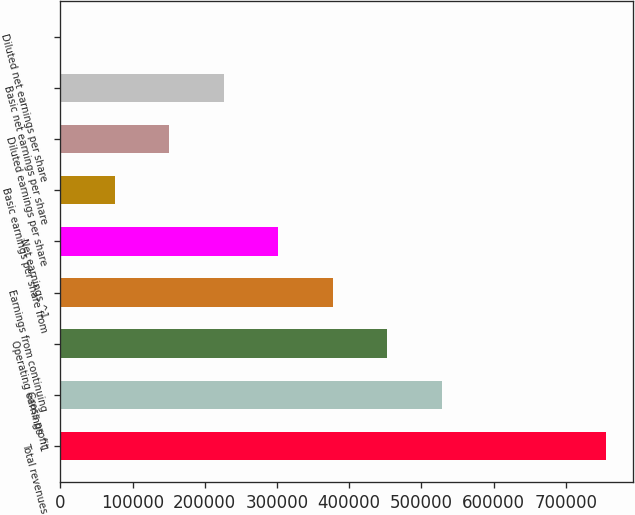<chart> <loc_0><loc_0><loc_500><loc_500><bar_chart><fcel>Total revenues<fcel>Gross profit<fcel>Operating earnings ^1<fcel>Earnings from continuing<fcel>Net earnings ^1<fcel>Basic earnings per share from<fcel>Diluted earnings per share<fcel>Basic net earnings per share<fcel>Diluted net earnings per share<nl><fcel>755027<fcel>528519<fcel>453016<fcel>377514<fcel>302011<fcel>75502.9<fcel>151006<fcel>226508<fcel>0.28<nl></chart> 